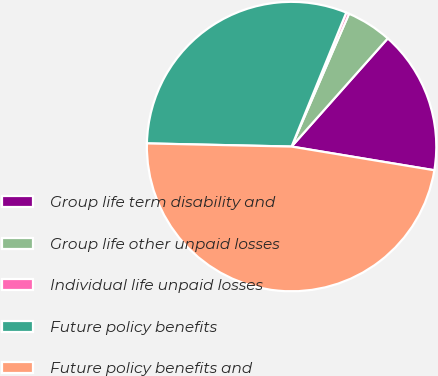Convert chart. <chart><loc_0><loc_0><loc_500><loc_500><pie_chart><fcel>Group life term disability and<fcel>Group life other unpaid losses<fcel>Individual life unpaid losses<fcel>Future policy benefits<fcel>Future policy benefits and<nl><fcel>16.05%<fcel>5.07%<fcel>0.33%<fcel>30.82%<fcel>47.73%<nl></chart> 